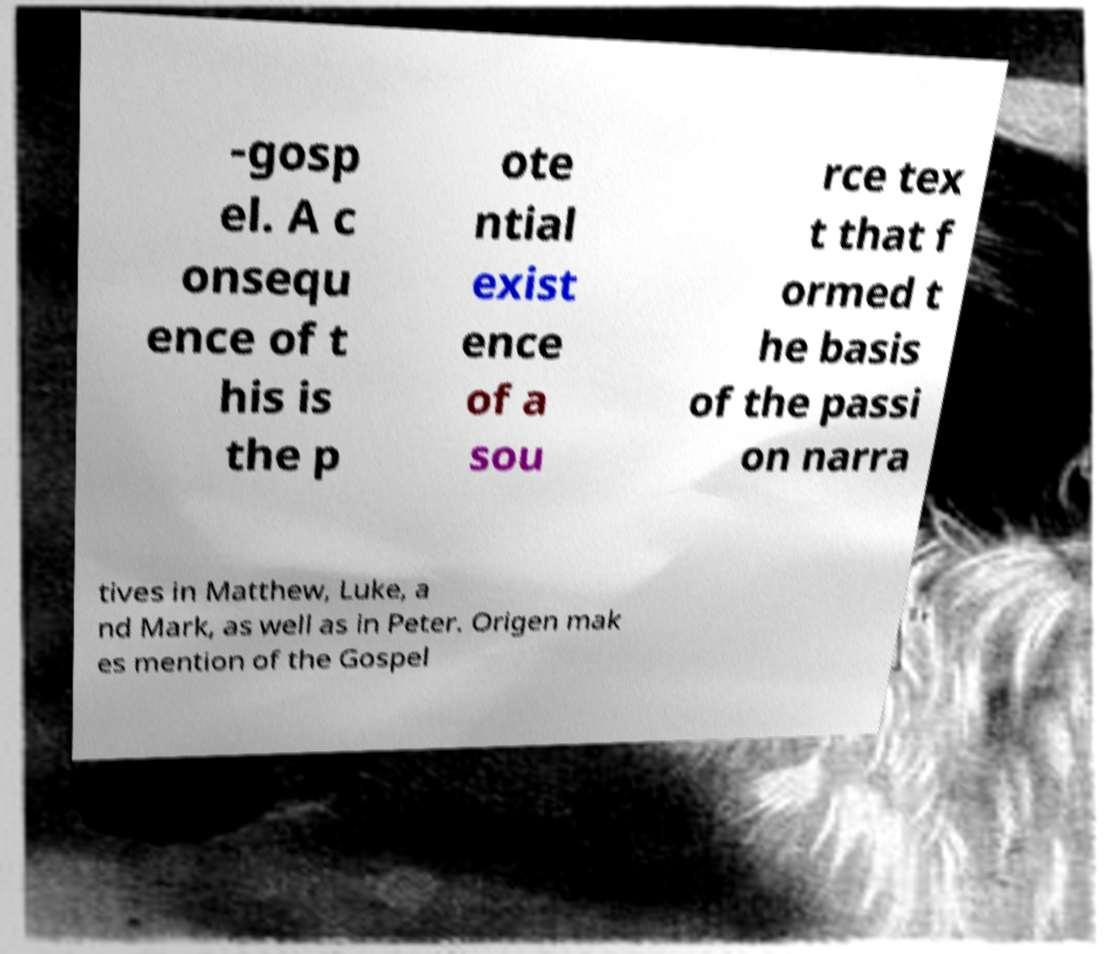Can you read and provide the text displayed in the image?This photo seems to have some interesting text. Can you extract and type it out for me? -gosp el. A c onsequ ence of t his is the p ote ntial exist ence of a sou rce tex t that f ormed t he basis of the passi on narra tives in Matthew, Luke, a nd Mark, as well as in Peter. Origen mak es mention of the Gospel 